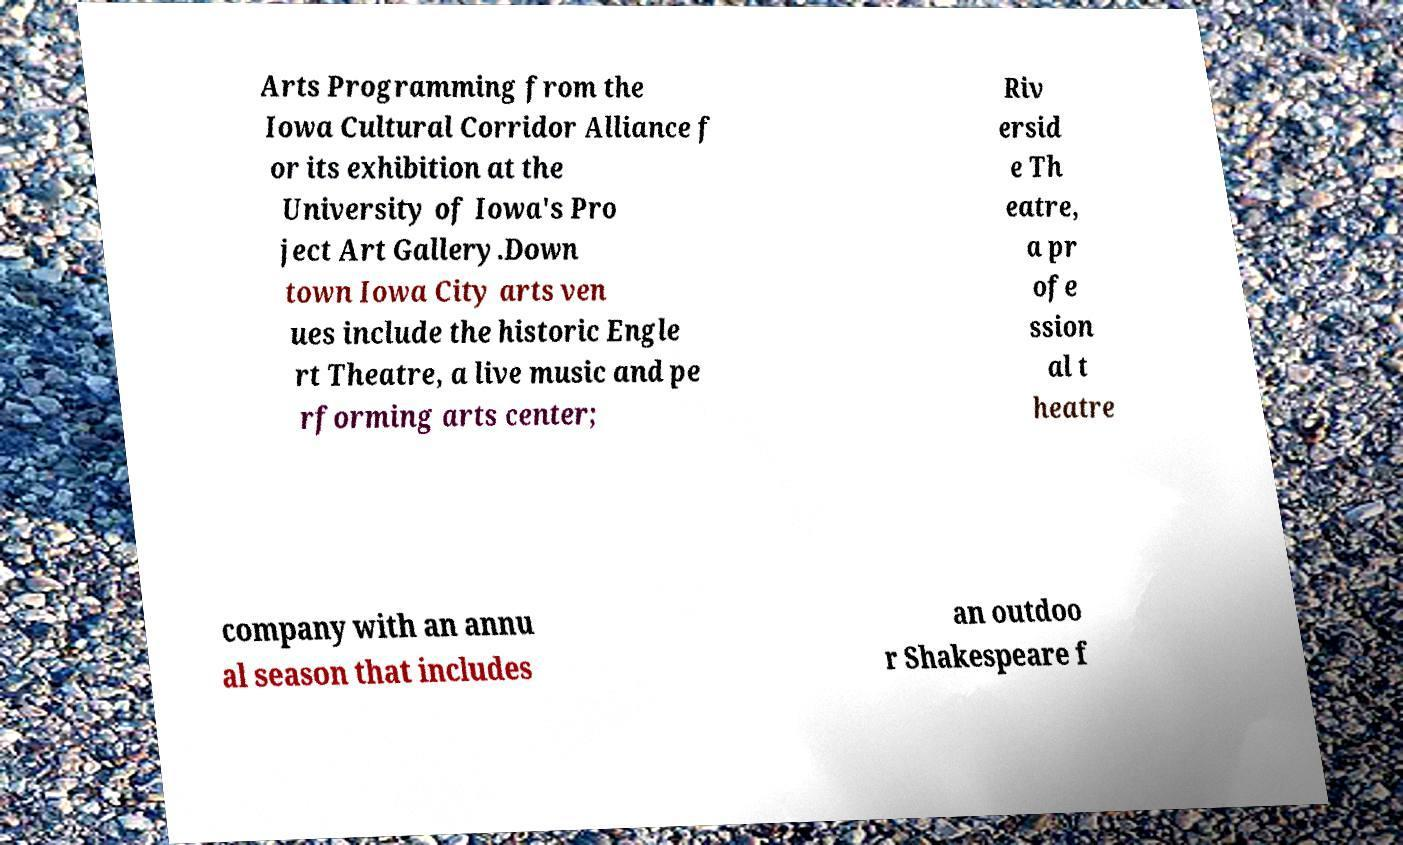What messages or text are displayed in this image? I need them in a readable, typed format. Arts Programming from the Iowa Cultural Corridor Alliance f or its exhibition at the University of Iowa's Pro ject Art Gallery.Down town Iowa City arts ven ues include the historic Engle rt Theatre, a live music and pe rforming arts center; Riv ersid e Th eatre, a pr ofe ssion al t heatre company with an annu al season that includes an outdoo r Shakespeare f 